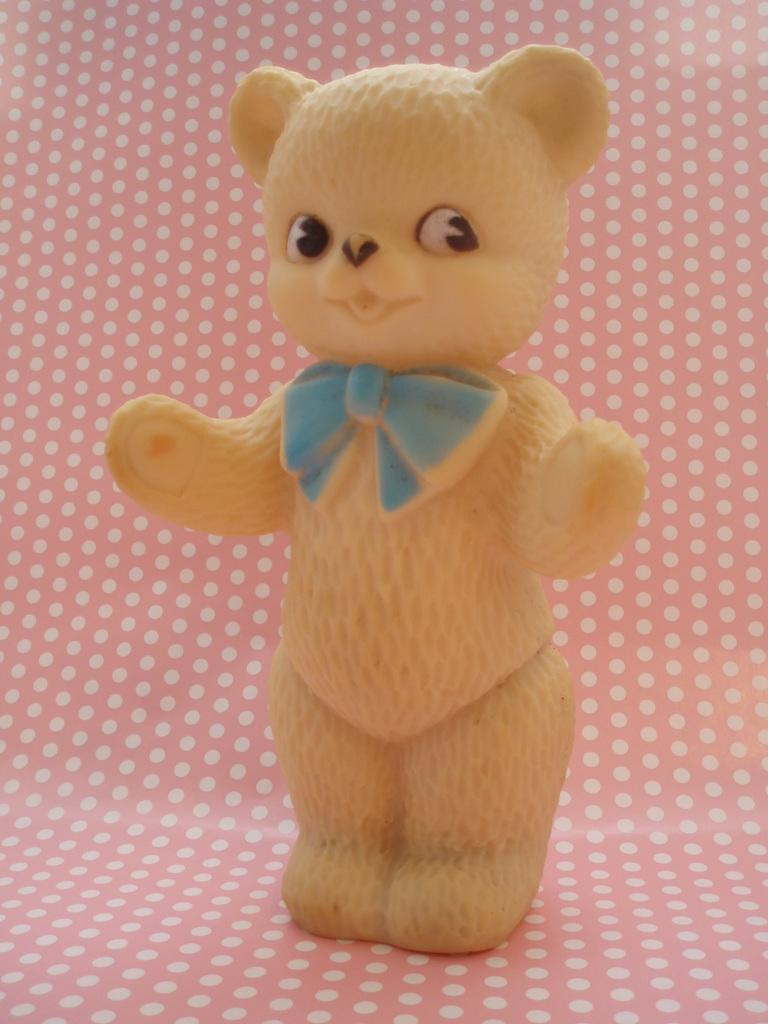What object can be seen in the image? There is a toy in the image. Where is the toy located? The toy is placed on a surface. What type of pan is being used to talk in the image? There is no pan or talking depicted in the image; it only features a toy placed on a surface. 